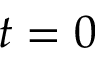<formula> <loc_0><loc_0><loc_500><loc_500>t = 0</formula> 